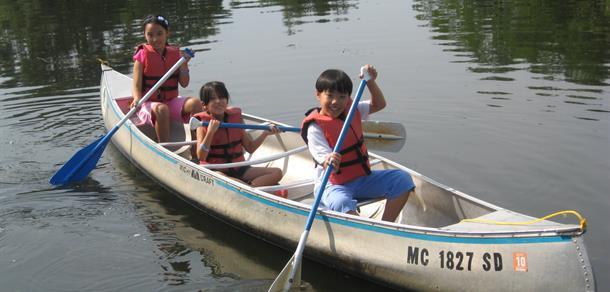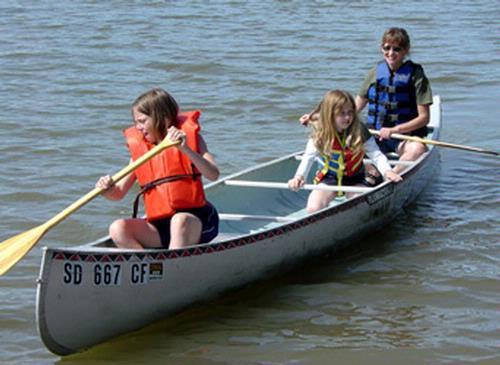The first image is the image on the left, the second image is the image on the right. Evaluate the accuracy of this statement regarding the images: "A red boat is in the water in the image on the left.". Is it true? Answer yes or no. No. The first image is the image on the left, the second image is the image on the right. For the images shown, is this caption "Right image shows a canoe holding three people who all wear red life vests." true? Answer yes or no. No. 